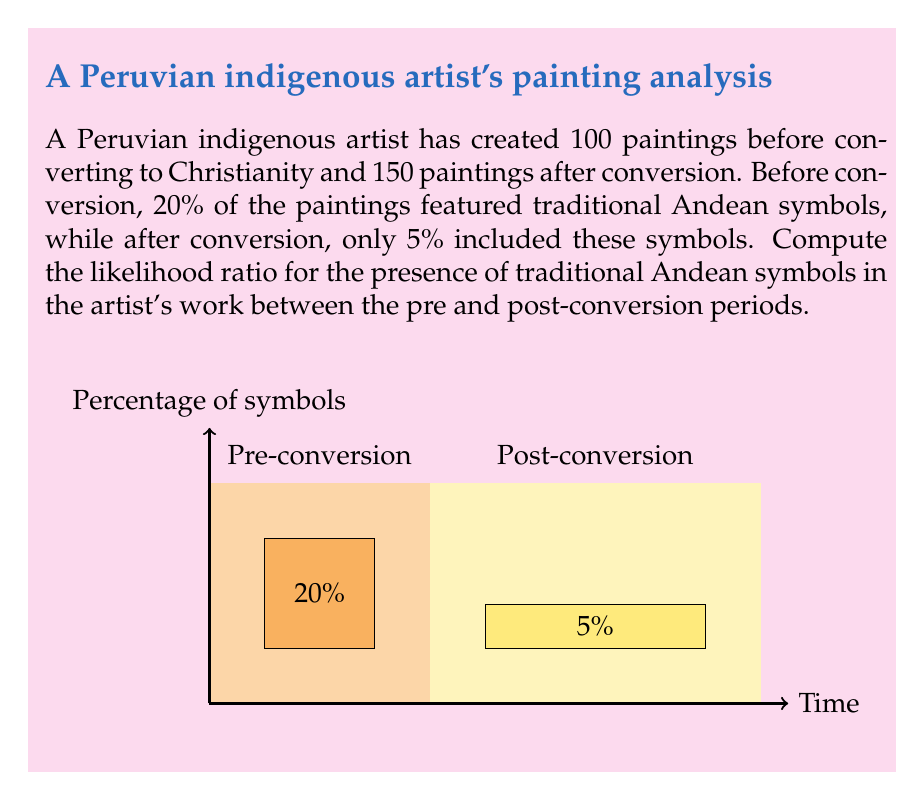Provide a solution to this math problem. To compute the likelihood ratio, we need to calculate the probability of observing traditional Andean symbols in the artist's work before and after conversion, then divide the former by the latter.

Let's define our events:
A: Presence of traditional Andean symbols
B: Pre-conversion period
C: Post-conversion period

We're given:
P(A|B) = 0.20 (20% of pre-conversion paintings had traditional symbols)
P(A|C) = 0.05 (5% of post-conversion paintings had traditional symbols)

The likelihood ratio (LR) is defined as:

$$ LR = \frac{P(A|B)}{P(A|C)} $$

Substituting the values:

$$ LR = \frac{0.20}{0.05} $$

$$ LR = 4 $$

This means that the presence of traditional Andean symbols in the artist's work is 4 times more likely in the pre-conversion period compared to the post-conversion period.

Interpretation: 
- If LR > 1: The evidence supports the pre-conversion hypothesis
- If LR < 1: The evidence supports the post-conversion hypothesis
- If LR = 1: The evidence is equally likely under both hypotheses

In this case, LR = 4 > 1, indicating strong support for the pre-conversion hypothesis in terms of the presence of traditional Andean symbols.
Answer: 4 